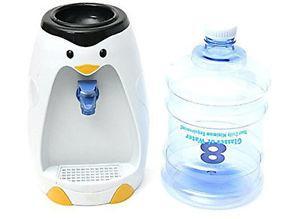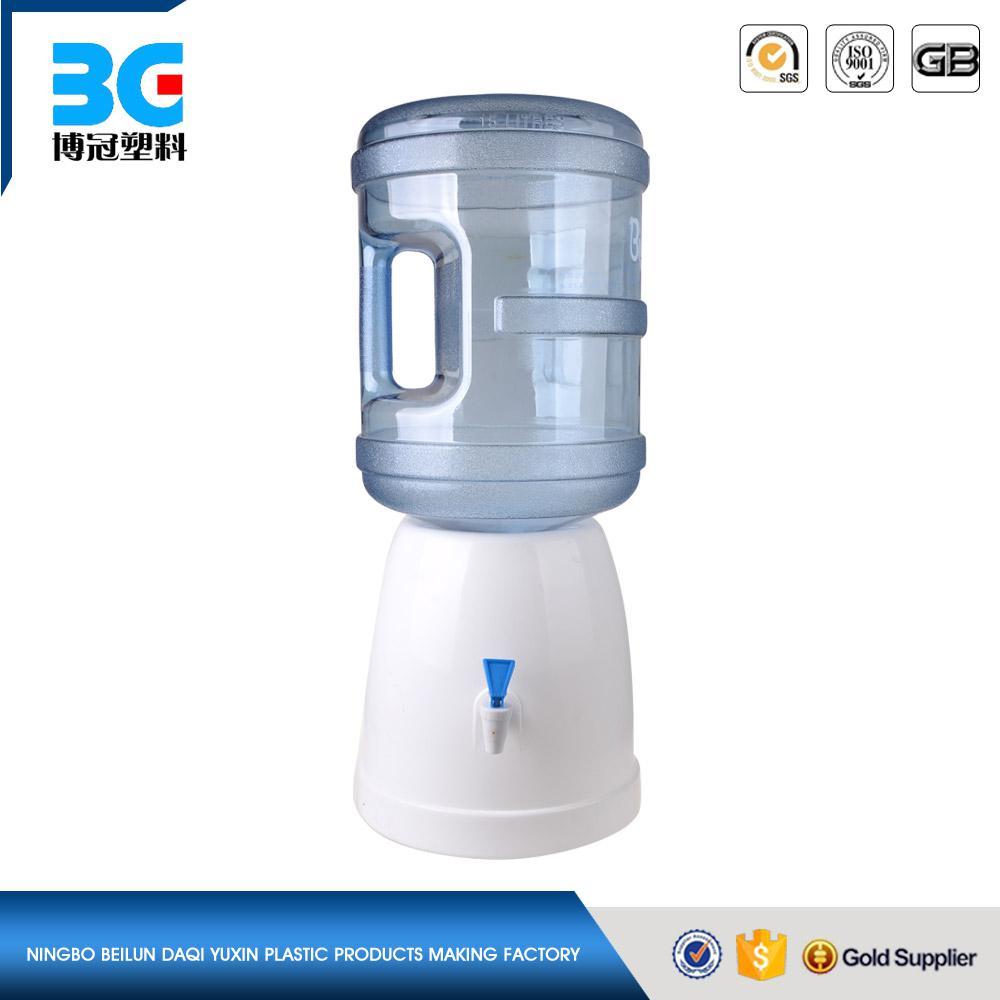The first image is the image on the left, the second image is the image on the right. For the images shown, is this caption "In at least one image there is a single water bottle twisted into a penguin water dispenser." true? Answer yes or no. No. The first image is the image on the left, the second image is the image on the right. Given the left and right images, does the statement "The right image shows an inverted blue water jug, and the left image includes a water jug and a dispenser that looks like a penguin." hold true? Answer yes or no. Yes. 